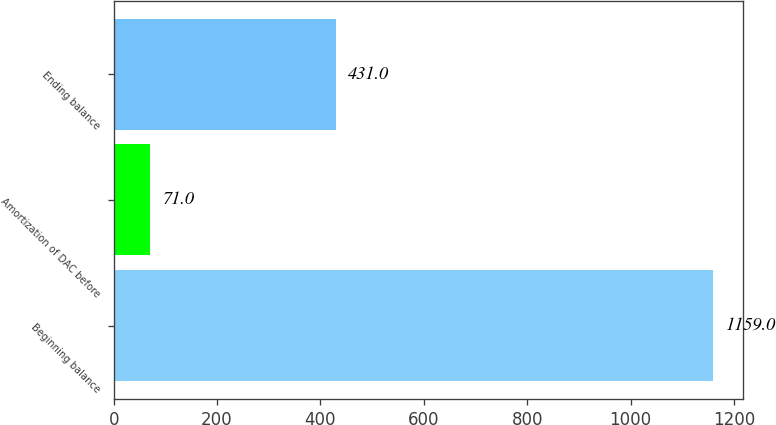Convert chart to OTSL. <chart><loc_0><loc_0><loc_500><loc_500><bar_chart><fcel>Beginning balance<fcel>Amortization of DAC before<fcel>Ending balance<nl><fcel>1159<fcel>71<fcel>431<nl></chart> 